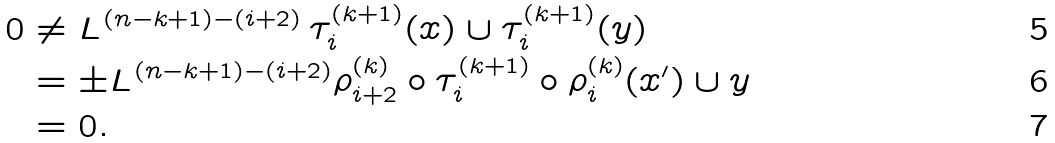<formula> <loc_0><loc_0><loc_500><loc_500>0 & \neq L ^ { ( n - k + 1 ) - ( i + 2 ) } \, \tau _ { i } ^ { ( k + 1 ) } ( x ) \cup \tau _ { i } ^ { ( k + 1 ) } ( y ) \\ & = \pm L ^ { ( n - k + 1 ) - ( i + 2 ) } \rho _ { i + 2 } ^ { ( k ) } \circ \tau _ { i } ^ { ( k + 1 ) } \circ \rho _ { i } ^ { ( k ) } ( x ^ { \prime } ) \cup y \\ & = 0 .</formula> 